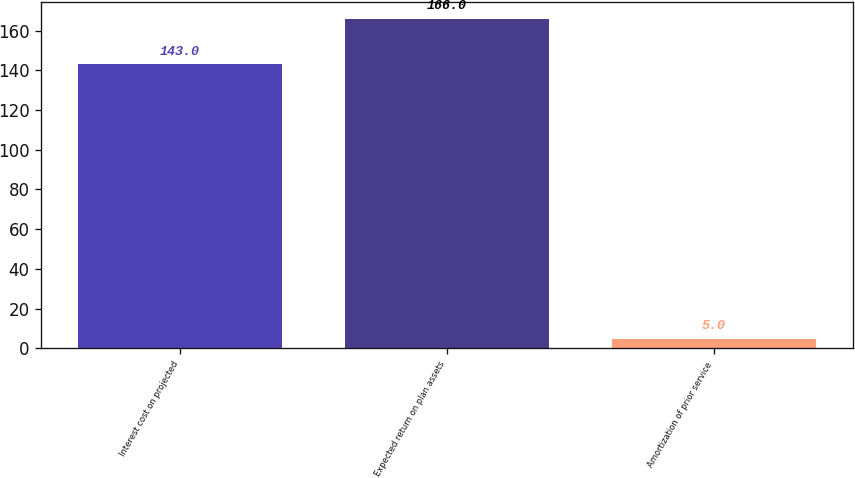<chart> <loc_0><loc_0><loc_500><loc_500><bar_chart><fcel>Interest cost on projected<fcel>Expected return on plan assets<fcel>Amortization of prior service<nl><fcel>143<fcel>166<fcel>5<nl></chart> 